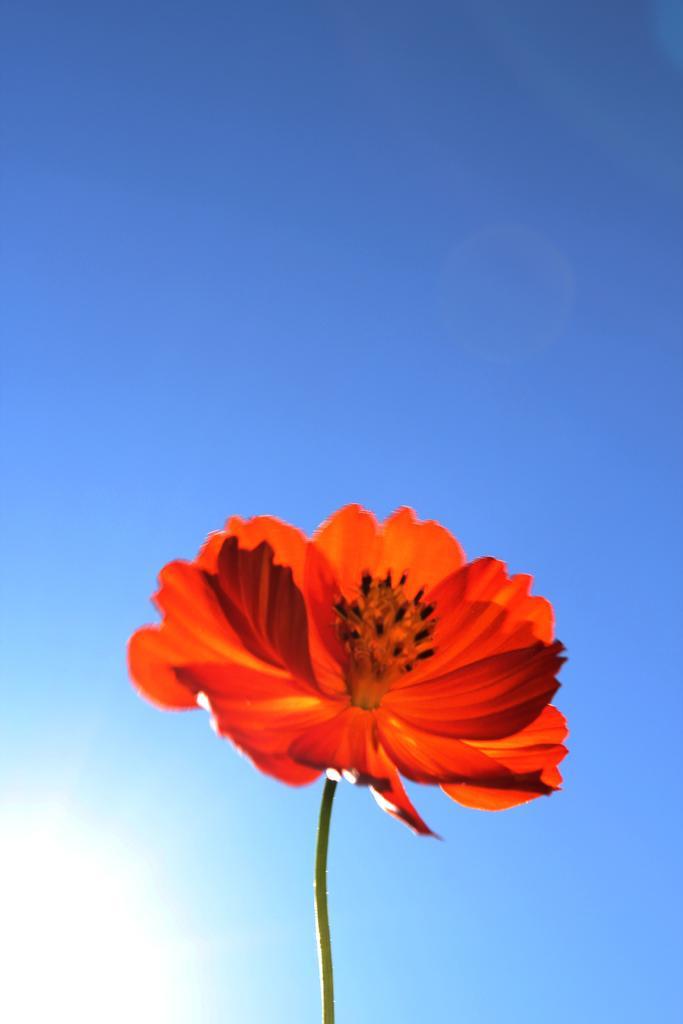Could you give a brief overview of what you see in this image? In this image there is a flower in the center. 